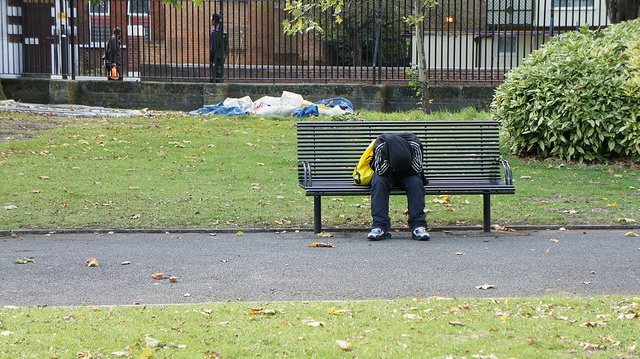Describe the objects in this image and their specific colors. I can see bench in gray, black, olive, darkgray, and navy tones, people in gray, black, and darkblue tones, people in gray, black, navy, and darkblue tones, people in gray, black, and maroon tones, and backpack in gray, gold, olive, black, and khaki tones in this image. 